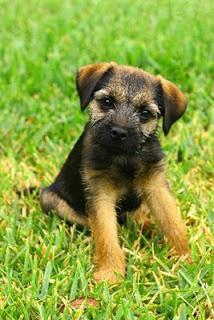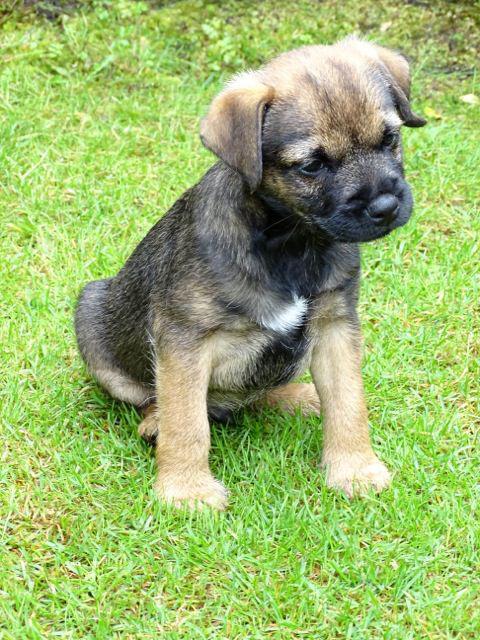The first image is the image on the left, the second image is the image on the right. Analyze the images presented: Is the assertion "Three dogs are relaxing outside in the grass." valid? Answer yes or no. No. The first image is the image on the left, the second image is the image on the right. Considering the images on both sides, is "There are three dogs exactly." valid? Answer yes or no. No. 